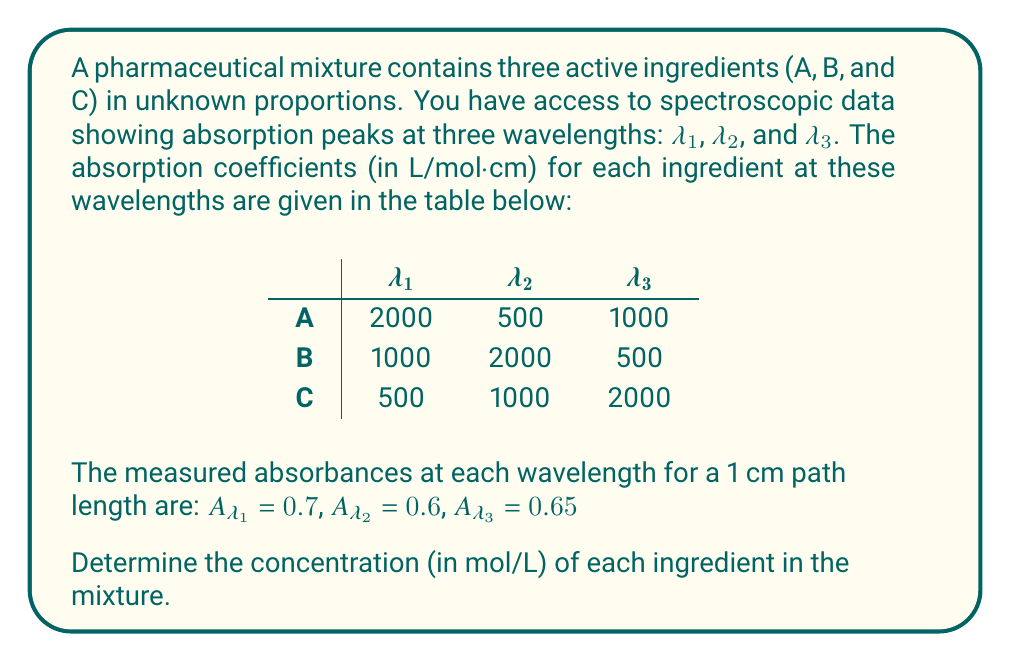Help me with this question. To solve this inverse problem, we'll use the Beer-Lambert law and set up a system of linear equations:

1) The Beer-Lambert law states that $A = \epsilon bc$, where $A$ is absorbance, $\epsilon$ is the absorption coefficient, $b$ is the path length (1 cm in this case), and $c$ is the concentration.

2) Let $x$, $y$, and $z$ be the concentrations of A, B, and C respectively. We can set up three equations based on the given data:

   $$2000x + 1000y + 500z = 0.7$$
   $$500x + 2000y + 1000z = 0.6$$
   $$1000x + 500y + 2000z = 0.65$$

3) We can represent this as a matrix equation $AX = B$:

   $$\begin{bmatrix}
   2000 & 1000 & 500 \\
   500 & 2000 & 1000 \\
   1000 & 500 & 2000
   \end{bmatrix}
   \begin{bmatrix}
   x \\
   y \\
   z
   \end{bmatrix} =
   \begin{bmatrix}
   0.7 \\
   0.6 \\
   0.65
   \end{bmatrix}$$

4) To solve this, we can use the inverse matrix method: $X = A^{-1}B$

5) Calculating the inverse of A and multiplying by B:

   $$\begin{bmatrix}
   x \\
   y \\
   z
   \end{bmatrix} =
   \frac{1}{5500000}
   \begin{bmatrix}
   3500 & -1000 & -500 \\
   -1000 & 3500 & -500 \\
   -500 & -1000 & 3500
   \end{bmatrix}
   \begin{bmatrix}
   0.7 \\
   0.6 \\
   0.65
   \end{bmatrix}$$

6) Performing the matrix multiplication:

   $$\begin{bmatrix}
   x \\
   y \\
   z
   \end{bmatrix} =
   \begin{bmatrix}
   0.0002 \\
   0.0001 \\
   0.0002
   \end{bmatrix}$$

Therefore, the concentrations are:
A: 0.0002 mol/L
B: 0.0001 mol/L
C: 0.0002 mol/L
Answer: A: 0.0002 mol/L, B: 0.0001 mol/L, C: 0.0002 mol/L 